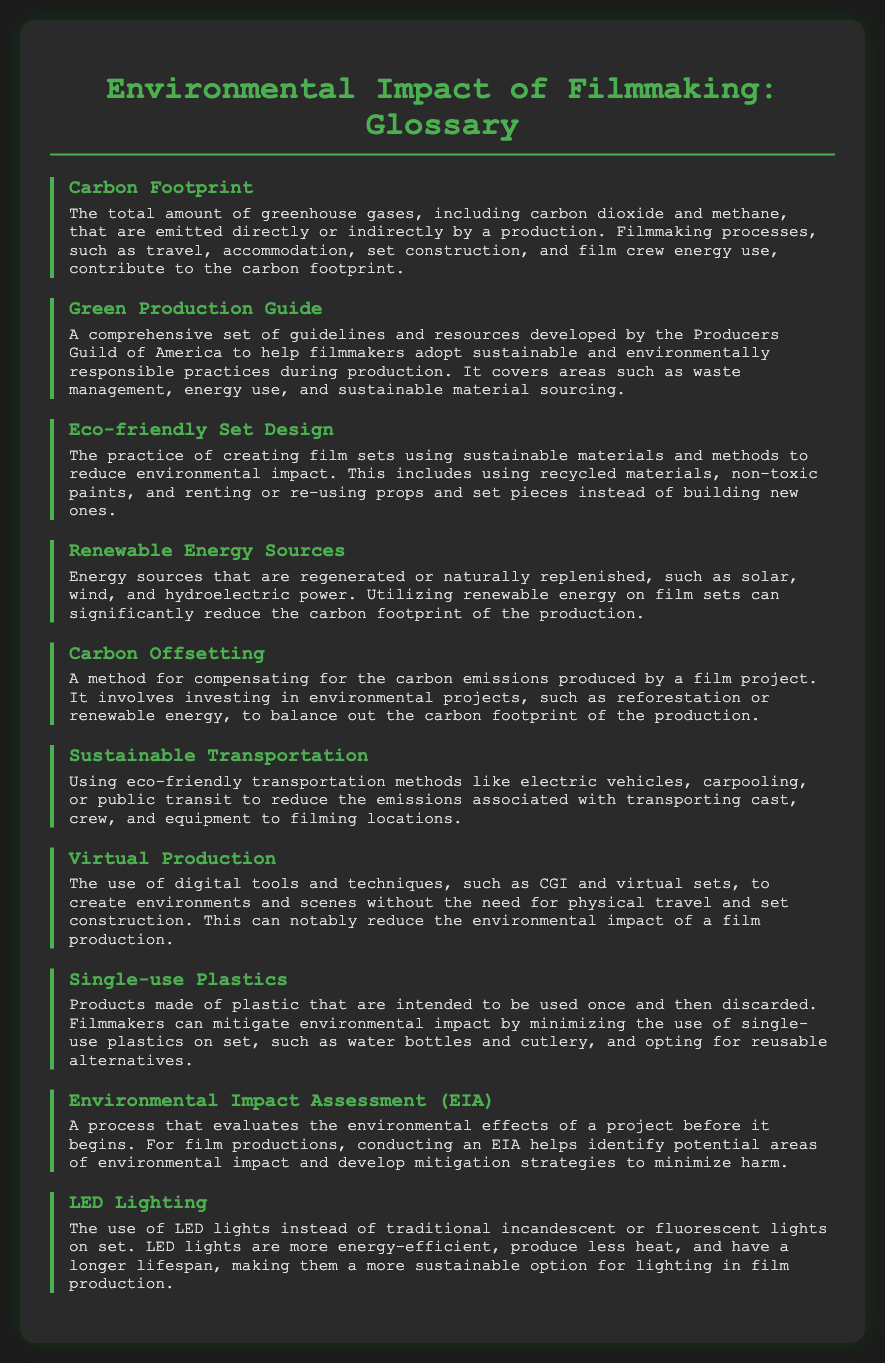What is the total amount of greenhouse gases emitted by a production? This refers to the definition provided for "Carbon Footprint," which states it is the total amount of greenhouse gases emitted directly or indirectly by a production.
Answer: Carbon Footprint What comprehensive set of guidelines helps filmmakers adopt sustainable practices? The answer is found under "Green Production Guide," which is described as a comprehensive set of guidelines and resources developed by the Producers Guild of America.
Answer: Green Production Guide What practice involves using sustainable materials in film sets? The definition of "Eco-friendly Set Design" specifies that it includes creating sets using sustainable materials and methods.
Answer: Eco-friendly Set Design Which energy sources are naturally replenished? The document defines "Renewable Energy Sources" as energy sources that are regenerated or naturally replenished.
Answer: Renewable Energy Sources What technique can significantly reduce the environmental impact of production? Under "Virtual Production," it describes using digital tools and techniques to create environments without physical travel, which can reduce environmental impact.
Answer: Virtual Production What method compensates for carbon emissions produced by a film project? "Carbon Offsetting" is defined as a method for compensating for carbon emissions by investing in environmental projects.
Answer: Carbon Offsetting What lighting technology is described as more energy-efficient? The term "LED Lighting" in the glossary defines lights that are more energy-efficient and sustainable compared to traditional options.
Answer: LED Lighting Which assessment helps identify environmental impacts before a project begins? "Environmental Impact Assessment (EIA)" is defined as a process that evaluates the environmental effects of a project before it begins.
Answer: Environmental Impact Assessment What is a common item on film sets that filmmakers are encouraged to minimize? The term "Single-use Plastics" highlights products intended to be used once and emphasizes minimizing their use on set.
Answer: Single-use Plastics What transportation method aims to reduce emissions in film production? The term "Sustainable Transportation" refers to using eco-friendly methods to reduce emissions associated with transporting people and equipment.
Answer: Sustainable Transportation 